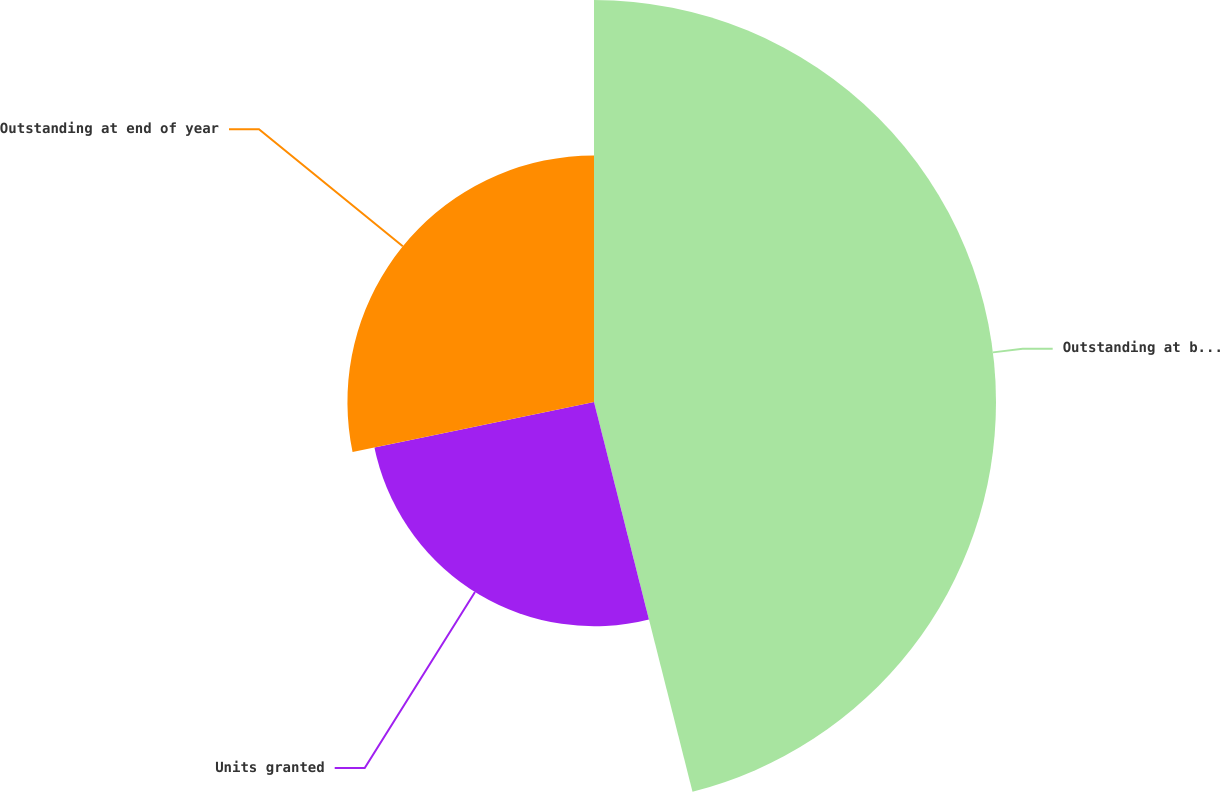<chart> <loc_0><loc_0><loc_500><loc_500><pie_chart><fcel>Outstanding at beginning of<fcel>Units granted<fcel>Outstanding at end of year<nl><fcel>46.06%<fcel>25.69%<fcel>28.25%<nl></chart> 